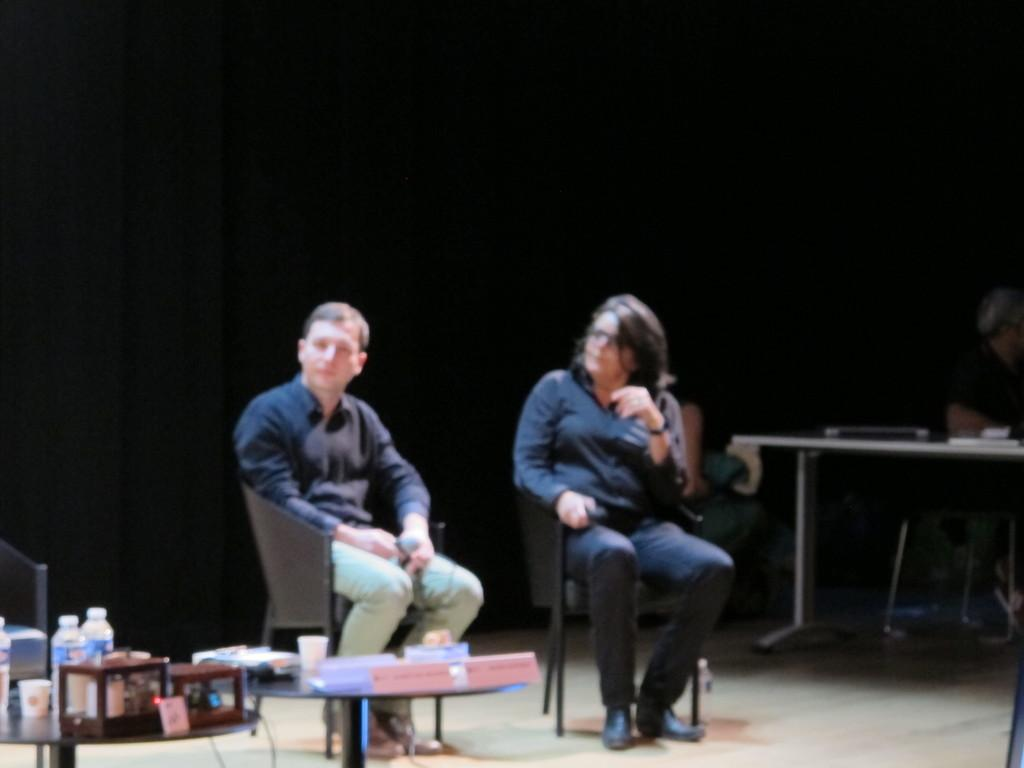How many men are sitting on chairs in the image? There are two men sitting on chairs in the image, one on the left side and one on the right side. What is the furniture piece between the two men? There is a glass table in the image. What items can be seen on the table? A glass and a bottle are present on the table. What advice does the mother give to the men in the image? There is no mother present in the image, so it is not possible to answer that question. 